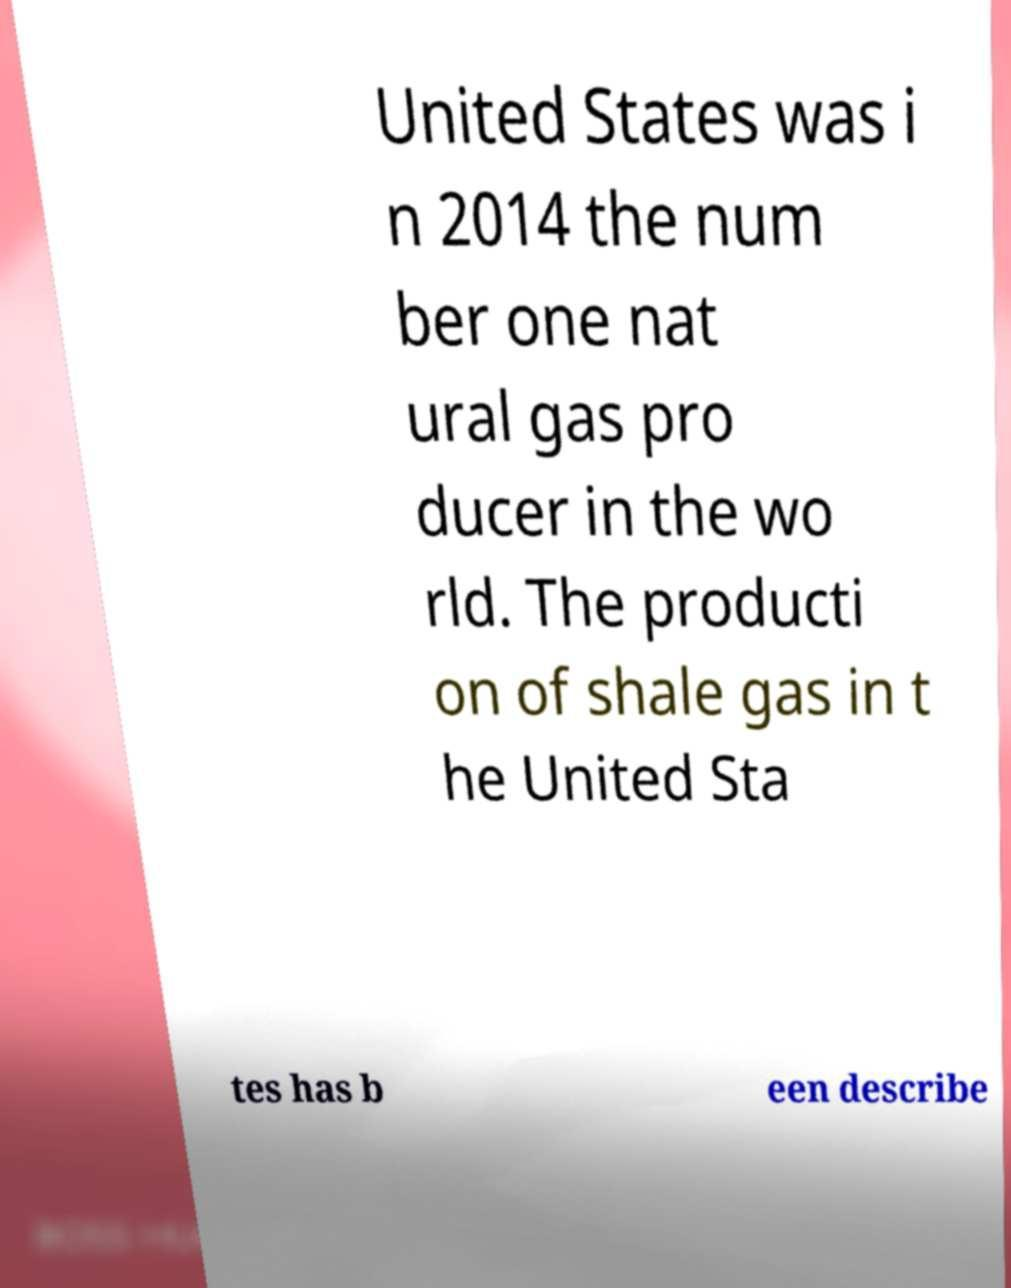What messages or text are displayed in this image? I need them in a readable, typed format. United States was i n 2014 the num ber one nat ural gas pro ducer in the wo rld. The producti on of shale gas in t he United Sta tes has b een describe 